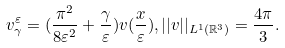<formula> <loc_0><loc_0><loc_500><loc_500>v _ { \gamma } ^ { \varepsilon } = ( \frac { \pi ^ { 2 } } { 8 \varepsilon ^ { 2 } } + \frac { \gamma } { \varepsilon } ) v ( \frac { x } { \varepsilon } ) , | | v | | _ { L ^ { 1 } ( \mathbb { R } ^ { 3 } ) } = \frac { 4 \pi } { 3 } .</formula> 